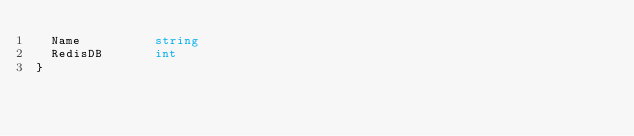<code> <loc_0><loc_0><loc_500><loc_500><_Go_>	Name          string
	RedisDB       int
}
</code> 